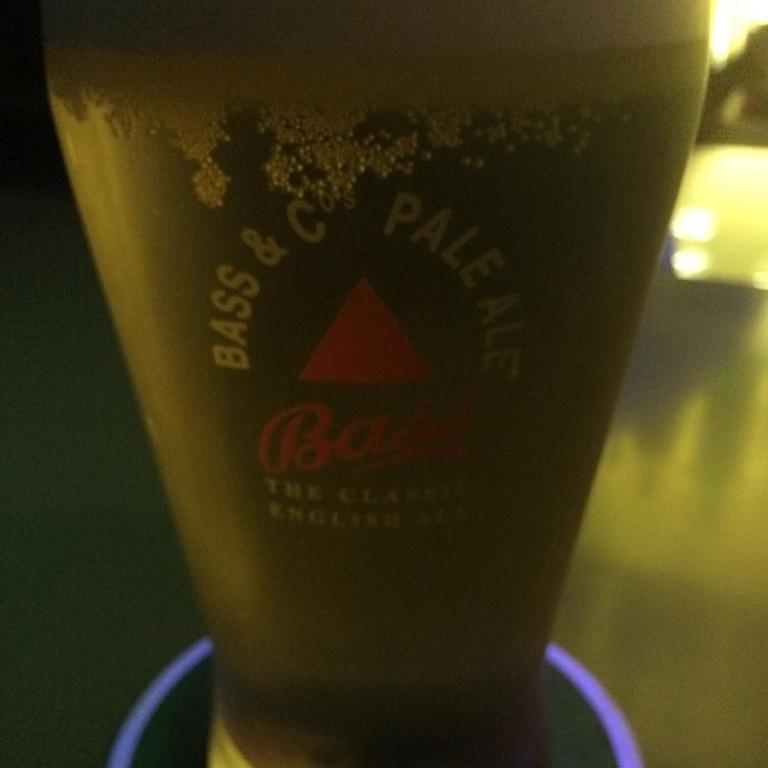Can you describe this image briefly? In this picture we can see a glass with drink in it, this glass is placed on a platform and in the background we can see it is blurry. 